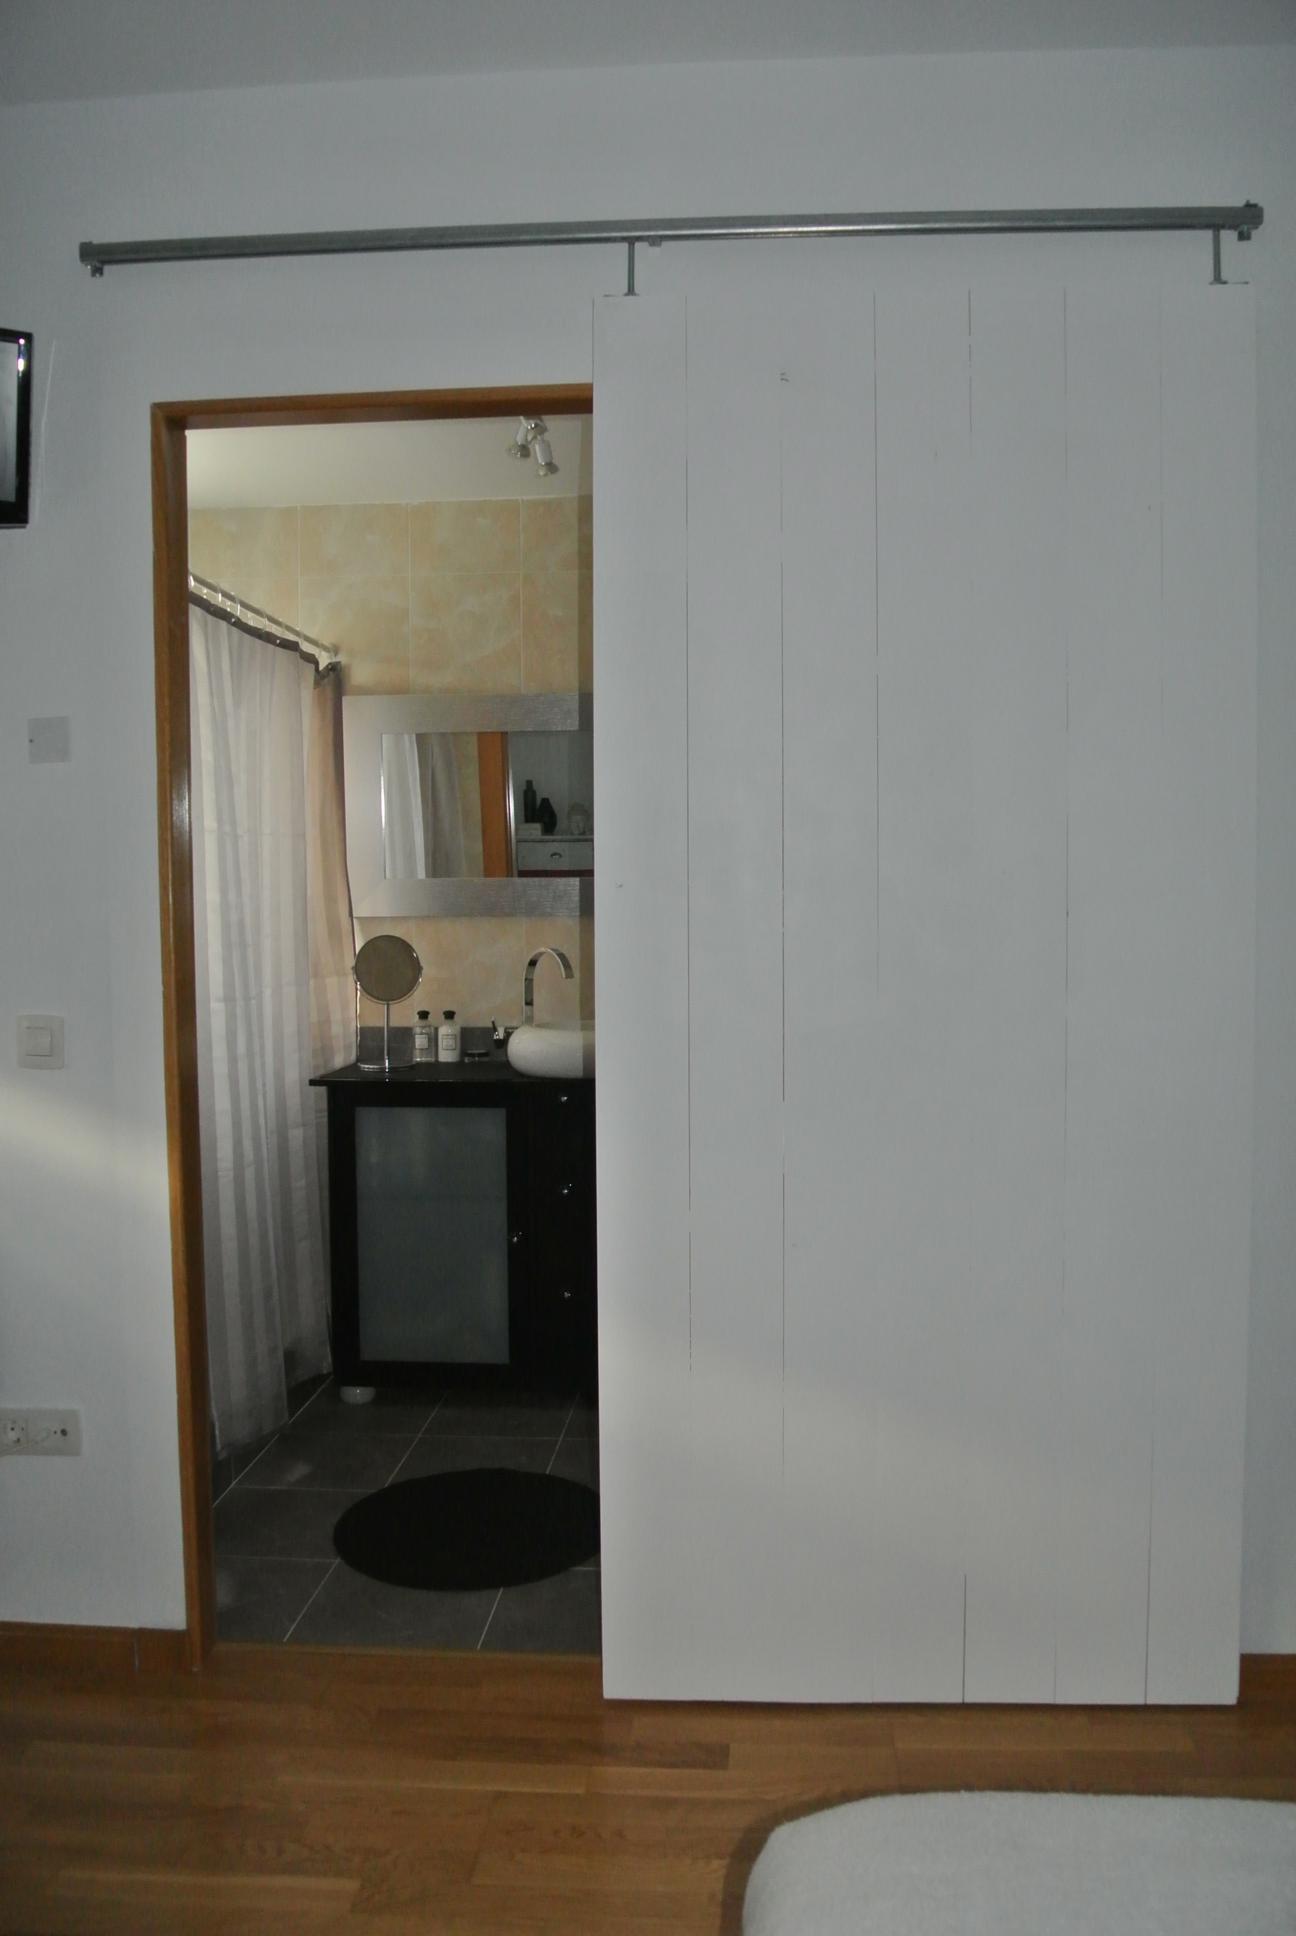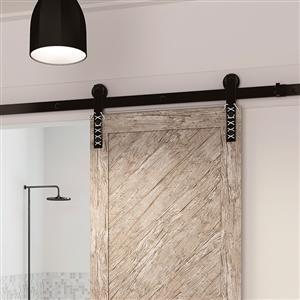The first image is the image on the left, the second image is the image on the right. Assess this claim about the two images: "There are two hanging door with at least one that has whitish horizontal lines that create five triangles.". Correct or not? Answer yes or no. No. 